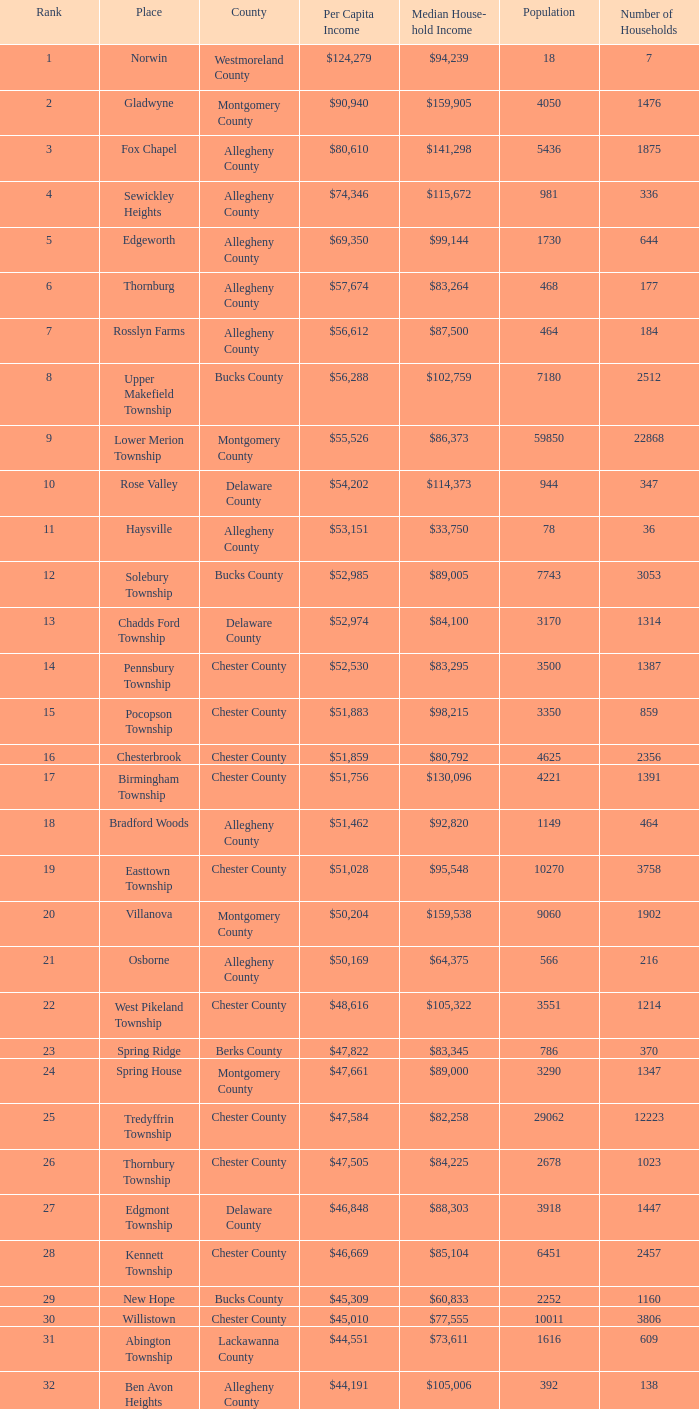What is the per capita income for Fayette County? $42,131. 